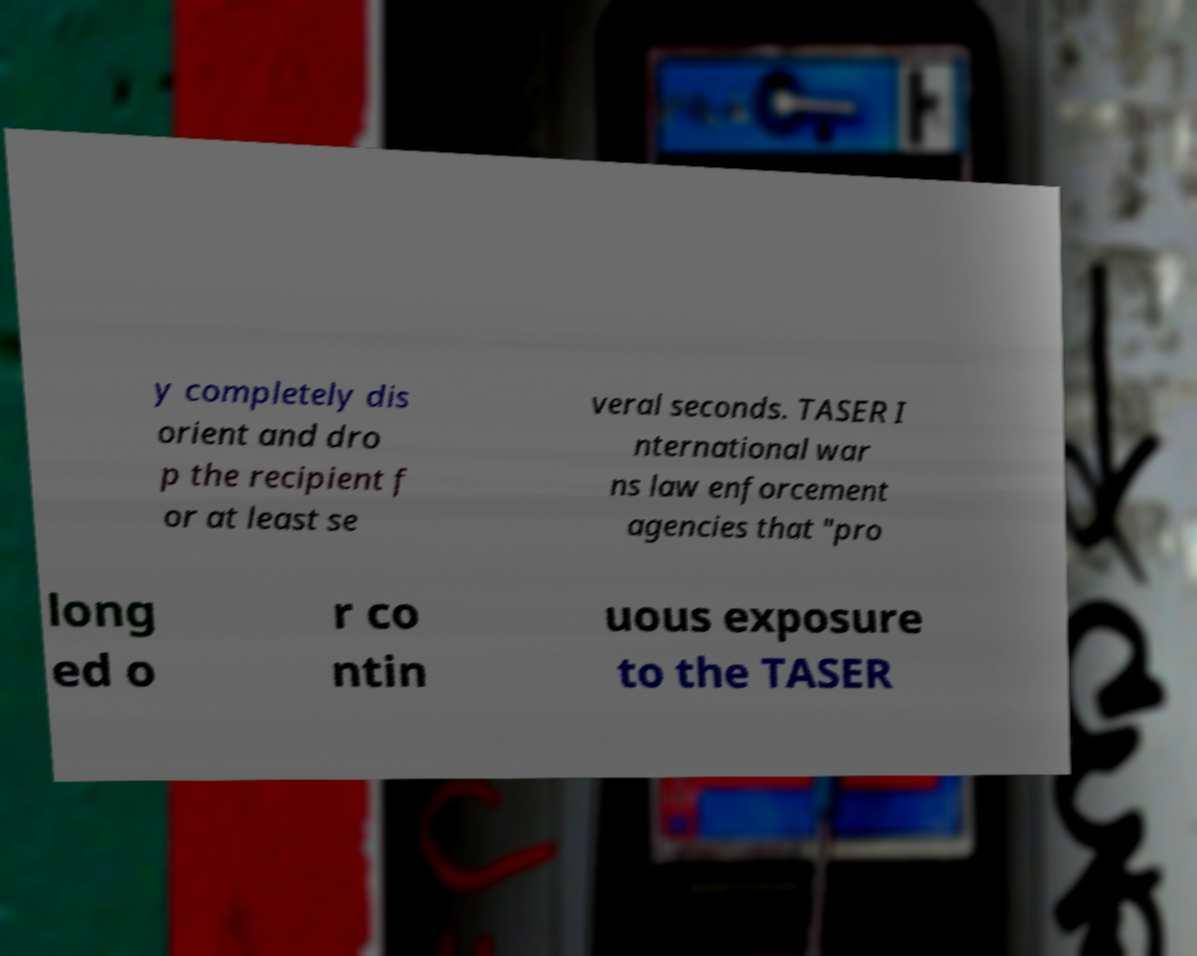Can you read and provide the text displayed in the image?This photo seems to have some interesting text. Can you extract and type it out for me? y completely dis orient and dro p the recipient f or at least se veral seconds. TASER I nternational war ns law enforcement agencies that "pro long ed o r co ntin uous exposure to the TASER 